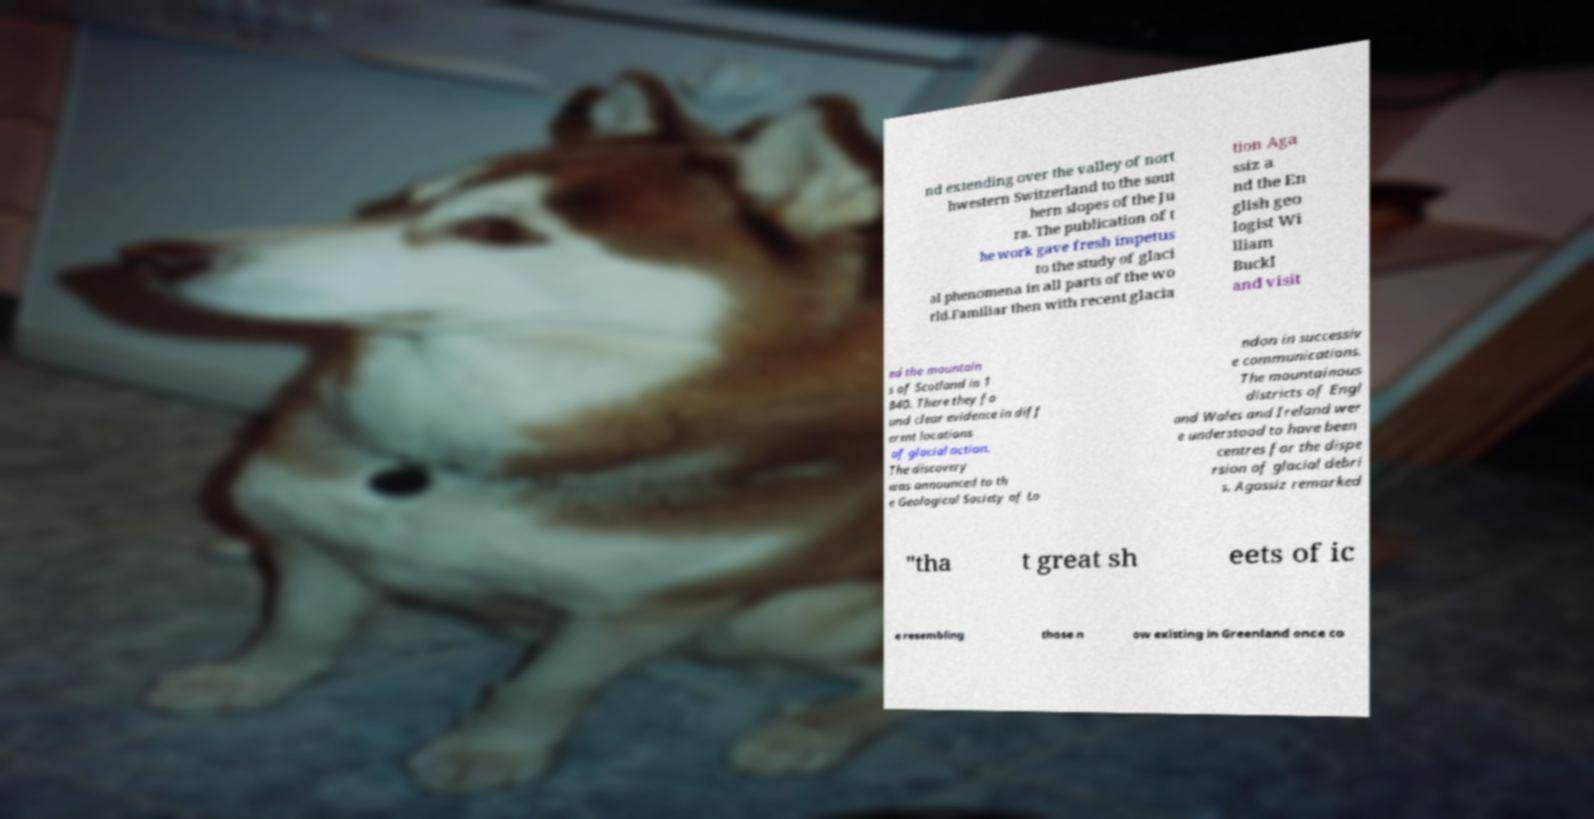Could you assist in decoding the text presented in this image and type it out clearly? nd extending over the valley of nort hwestern Switzerland to the sout hern slopes of the Ju ra. The publication of t he work gave fresh impetus to the study of glaci al phenomena in all parts of the wo rld.Familiar then with recent glacia tion Aga ssiz a nd the En glish geo logist Wi lliam Buckl and visit ed the mountain s of Scotland in 1 840. There they fo und clear evidence in diff erent locations of glacial action. The discovery was announced to th e Geological Society of Lo ndon in successiv e communications. The mountainous districts of Engl and Wales and Ireland wer e understood to have been centres for the dispe rsion of glacial debri s. Agassiz remarked "tha t great sh eets of ic e resembling those n ow existing in Greenland once co 